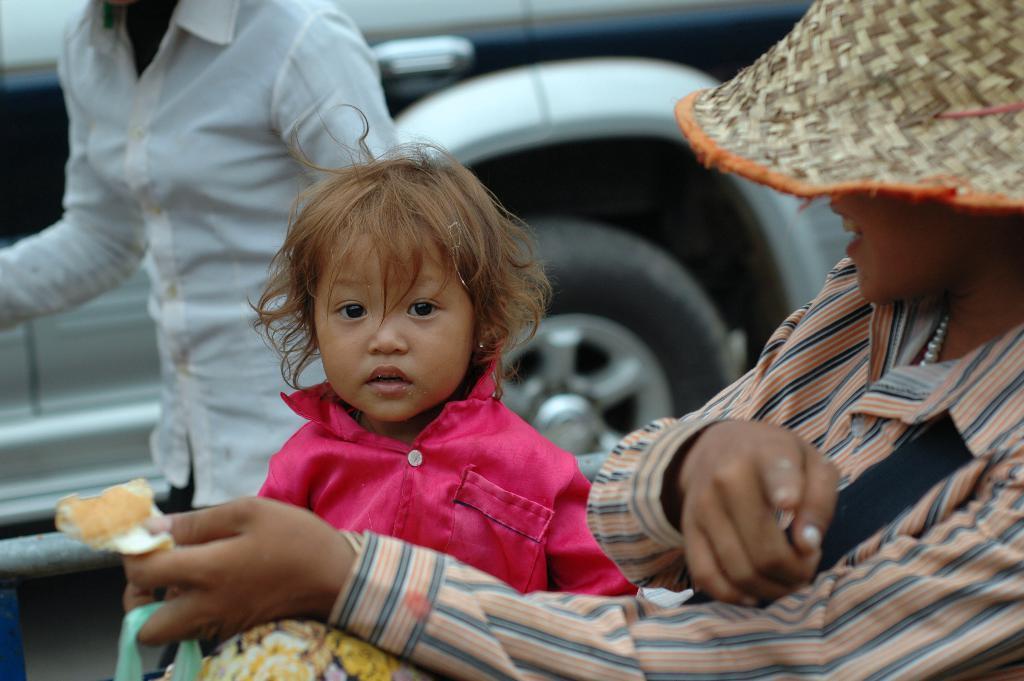In one or two sentences, can you explain what this image depicts? In this picture I can see two people and a child. The person on the right side is wearing a hat and holding something in the hand. In the background I can see a vehicle on the ground. 